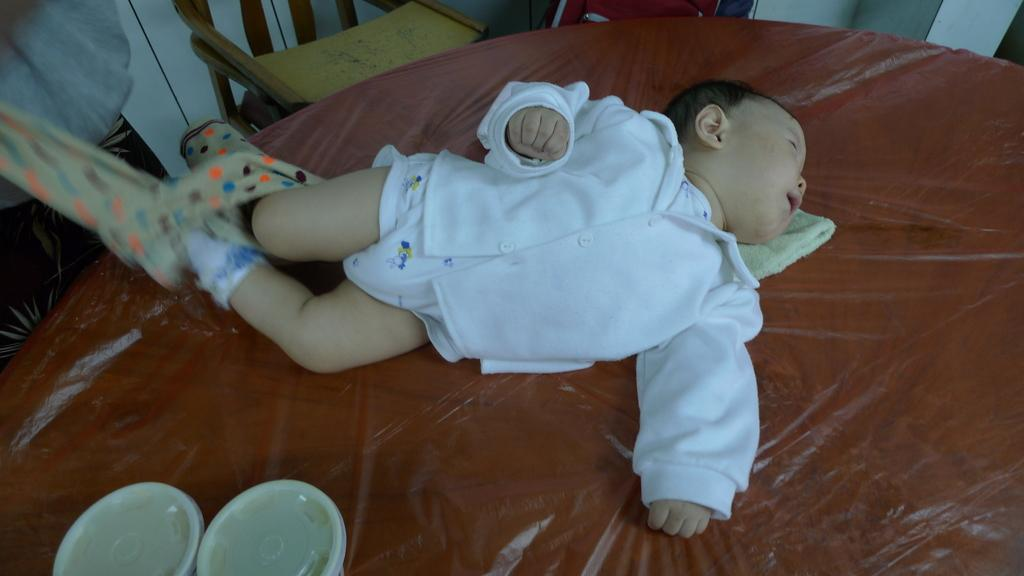What is the main subject of the image? There is a baby sleeping in the center of the image. Where is the baby located? The baby is on a bed. What else can be seen on the bed? There are boxes and a towel on the bed. What can be seen in the background of the image? There is a chair and a wall in the background of the image. What type of cherry is being used as a pillow for the baby in the image? There is no cherry present in the image; the baby is using a towel as a pillow. On which side of the bed is the desk located in the image? There is no desk present in the image. 